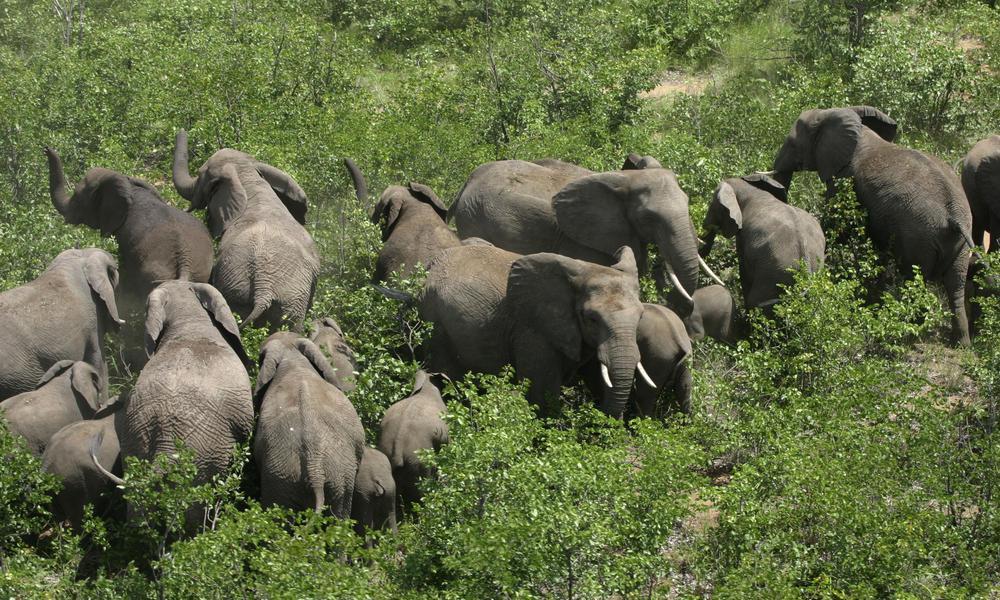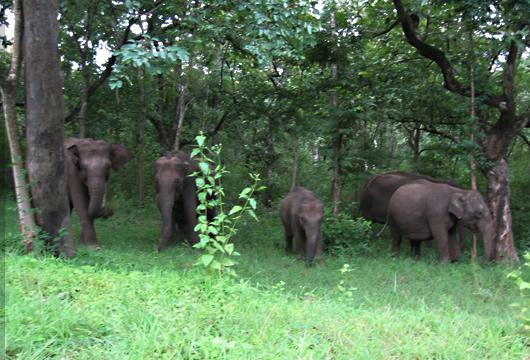The first image is the image on the left, the second image is the image on the right. Considering the images on both sides, is "An image features just one elephant, which has large tusks." valid? Answer yes or no. No. 